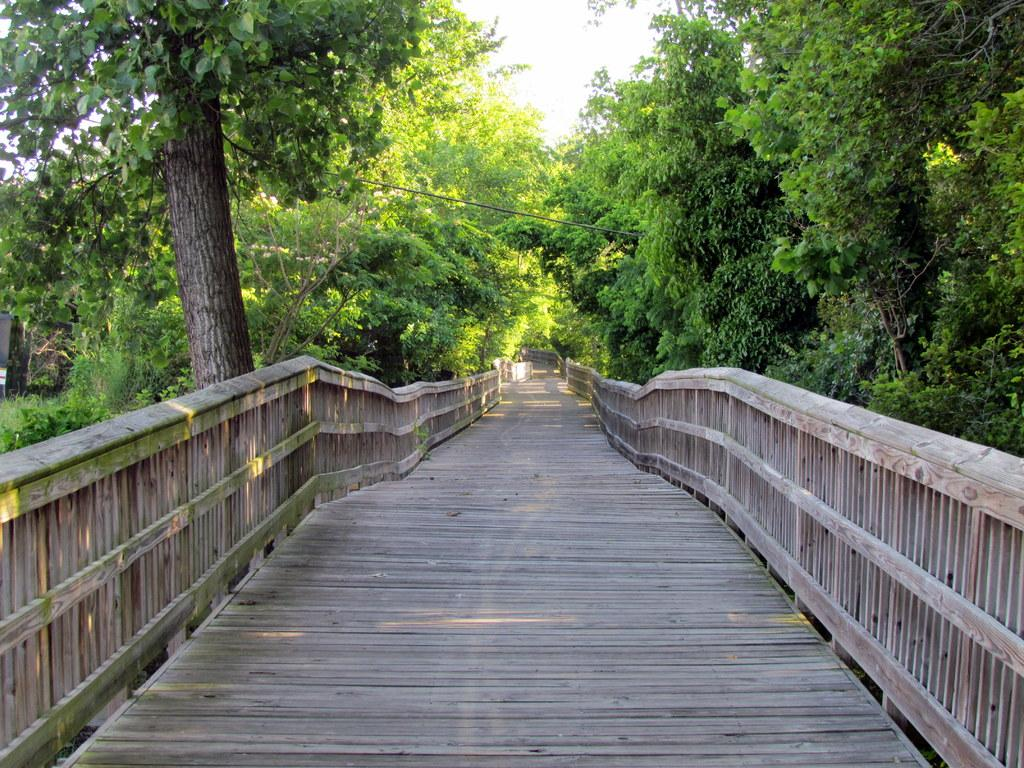What type of pathway is present in the image? There is a wooden walkway in the image. What can be seen on the left side of the image? There are trees on the left side of the image. What can be seen on the right side of the image? There are trees on the right side of the image. What is visible at the top of the image? The sky is clear and visible at the top of the image. What type of prose can be heard being read aloud in the image? There is no indication in the image that any prose is being read aloud. Can you identify any cactus plants in the image? There are no cactus plants present in the image; only trees are visible. 